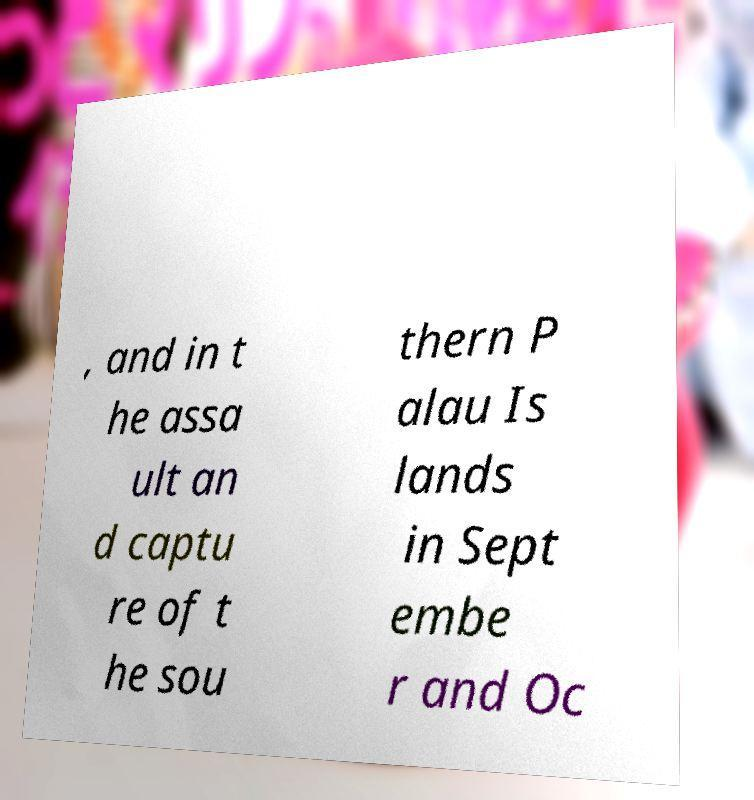Can you read and provide the text displayed in the image?This photo seems to have some interesting text. Can you extract and type it out for me? , and in t he assa ult an d captu re of t he sou thern P alau Is lands in Sept embe r and Oc 